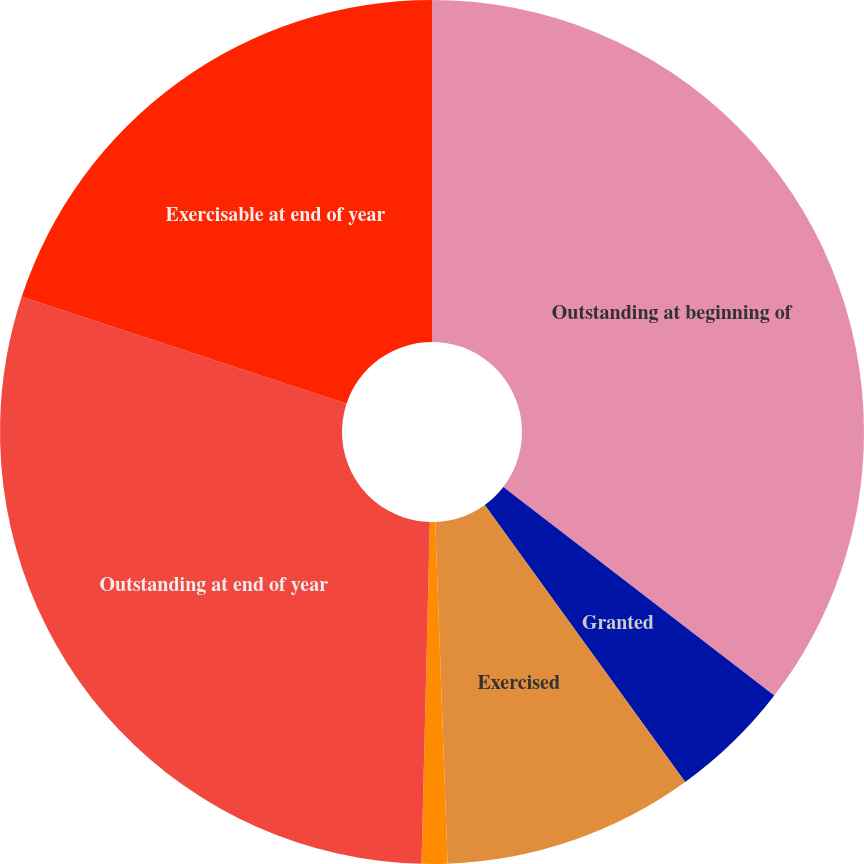<chart> <loc_0><loc_0><loc_500><loc_500><pie_chart><fcel>Outstanding at beginning of<fcel>Granted<fcel>Exercised<fcel>Expired or canceled<fcel>Outstanding at end of year<fcel>Exercisable at end of year<nl><fcel>35.44%<fcel>4.59%<fcel>9.39%<fcel>0.96%<fcel>29.68%<fcel>19.93%<nl></chart> 